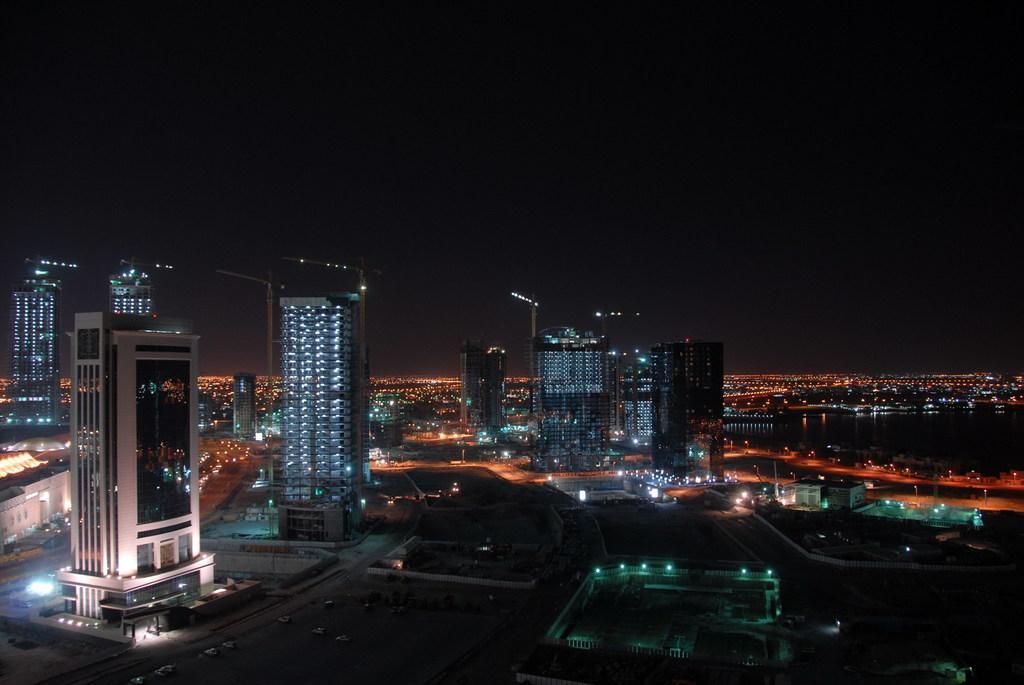Could you give a brief overview of what you see in this image? In this picture there are buildings, poles, and lights in the center of the image and there is sky at the top side of the image, it seems to be the picture is captured during night time. 